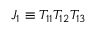<formula> <loc_0><loc_0><loc_500><loc_500>J _ { 1 } \equiv T _ { 1 1 } T _ { 1 2 } T _ { 1 3 }</formula> 